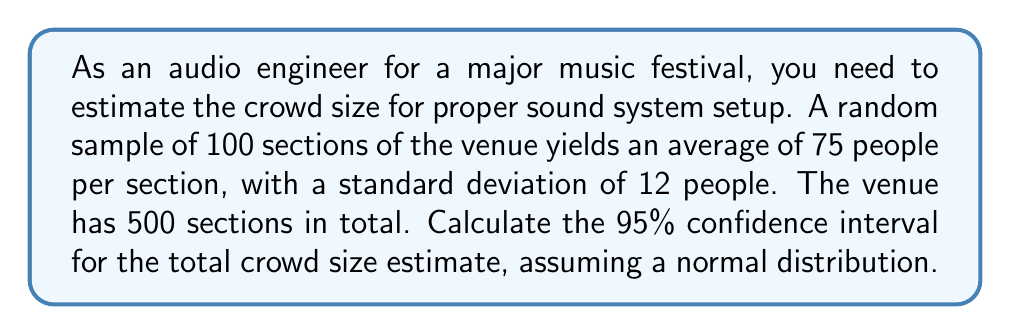Can you solve this math problem? Let's approach this step-by-step:

1) First, we need to calculate the standard error of the mean (SEM):
   $SEM = \frac{s}{\sqrt{n}}$ where s is the sample standard deviation and n is the sample size
   $SEM = \frac{12}{\sqrt{100}} = 1.2$

2) For a 95% confidence interval, we use a z-score of 1.96 (from the standard normal distribution table)

3) The margin of error is:
   $Margin of Error = z \times SEM = 1.96 \times 1.2 = 2.352$

4) The confidence interval for the mean number of people per section is:
   $CI = \bar{x} \pm Margin of Error = 75 \pm 2.352 = (72.648, 77.352)$

5) To get the total crowd size estimate, we multiply by the total number of sections:
   Lower bound: $72.648 \times 500 = 36,324$
   Upper bound: $77.352 \times 500 = 38,676$

Therefore, the 95% confidence interval for the total crowd size is (36,324, 38,676).
Answer: (36,324, 38,676) 